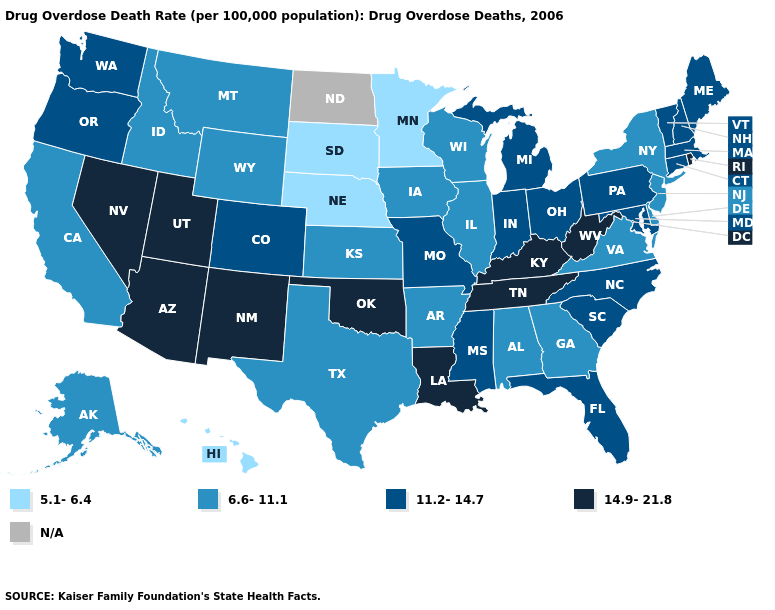Among the states that border Minnesota , which have the highest value?
Short answer required. Iowa, Wisconsin. Does the map have missing data?
Keep it brief. Yes. Which states have the lowest value in the MidWest?
Short answer required. Minnesota, Nebraska, South Dakota. What is the highest value in the USA?
Quick response, please. 14.9-21.8. Does Louisiana have the highest value in the South?
Concise answer only. Yes. Does Missouri have the highest value in the MidWest?
Write a very short answer. Yes. Is the legend a continuous bar?
Answer briefly. No. Name the states that have a value in the range 11.2-14.7?
Write a very short answer. Colorado, Connecticut, Florida, Indiana, Maine, Maryland, Massachusetts, Michigan, Mississippi, Missouri, New Hampshire, North Carolina, Ohio, Oregon, Pennsylvania, South Carolina, Vermont, Washington. Name the states that have a value in the range 11.2-14.7?
Keep it brief. Colorado, Connecticut, Florida, Indiana, Maine, Maryland, Massachusetts, Michigan, Mississippi, Missouri, New Hampshire, North Carolina, Ohio, Oregon, Pennsylvania, South Carolina, Vermont, Washington. Which states have the lowest value in the West?
Quick response, please. Hawaii. Name the states that have a value in the range 6.6-11.1?
Short answer required. Alabama, Alaska, Arkansas, California, Delaware, Georgia, Idaho, Illinois, Iowa, Kansas, Montana, New Jersey, New York, Texas, Virginia, Wisconsin, Wyoming. Which states have the lowest value in the MidWest?
Concise answer only. Minnesota, Nebraska, South Dakota. What is the lowest value in the USA?
Write a very short answer. 5.1-6.4. What is the value of Florida?
Answer briefly. 11.2-14.7. Among the states that border New York , which have the lowest value?
Answer briefly. New Jersey. 